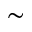<formula> <loc_0><loc_0><loc_500><loc_500>\sim</formula> 